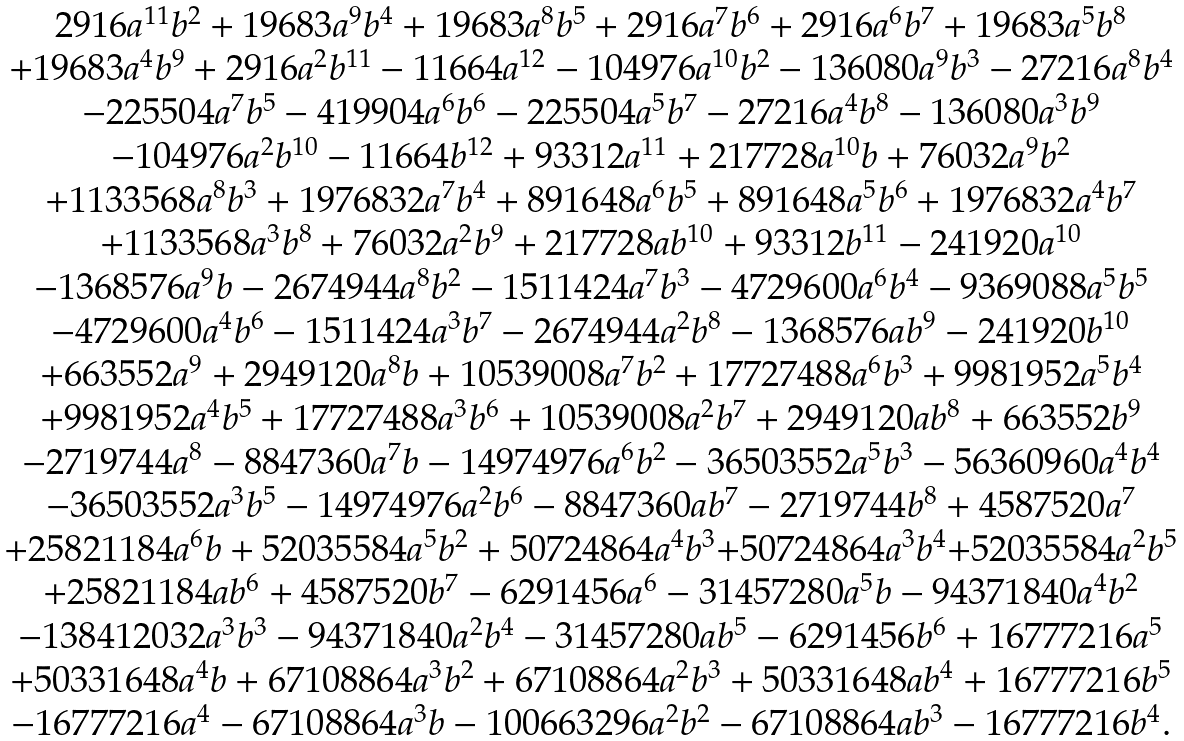Convert formula to latex. <formula><loc_0><loc_0><loc_500><loc_500>\begin{matrix} & 2 9 1 6 a ^ { 1 1 } b ^ { 2 } + 1 9 6 8 3 a ^ { 9 } b ^ { 4 } + 1 9 6 8 3 a ^ { 8 } b ^ { 5 } + 2 9 1 6 a ^ { 7 } b ^ { 6 } + 2 9 1 6 a ^ { 6 } b ^ { 7 } + 1 9 6 8 3 a ^ { 5 } b ^ { 8 } \\ & + 1 9 6 8 3 a ^ { 4 } b ^ { 9 } + 2 9 1 6 a ^ { 2 } b ^ { 1 1 } - 1 1 6 6 4 a ^ { 1 2 } - 1 0 4 9 7 6 a ^ { 1 0 } b ^ { 2 } - 1 3 6 0 8 0 a ^ { 9 } b ^ { 3 } - 2 7 2 1 6 a ^ { 8 } b ^ { 4 } \\ & - 2 2 5 5 0 4 a ^ { 7 } b ^ { 5 } - 4 1 9 9 0 4 a ^ { 6 } b ^ { 6 } - 2 2 5 5 0 4 a ^ { 5 } b ^ { 7 } - 2 7 2 1 6 a ^ { 4 } b ^ { 8 } - 1 3 6 0 8 0 a ^ { 3 } b ^ { 9 } \\ & - 1 0 4 9 7 6 a ^ { 2 } b ^ { 1 0 } - 1 1 6 6 4 b ^ { 1 2 } + 9 3 3 1 2 a ^ { 1 1 } + 2 1 7 7 2 8 a ^ { 1 0 } b + 7 6 0 3 2 a ^ { 9 } b ^ { 2 } \\ & + 1 1 3 3 5 6 8 a ^ { 8 } b ^ { 3 } + 1 9 7 6 8 3 2 a ^ { 7 } b ^ { 4 } + 8 9 1 6 4 8 a ^ { 6 } b ^ { 5 } + 8 9 1 6 4 8 a ^ { 5 } b ^ { 6 } + 1 9 7 6 8 3 2 a ^ { 4 } b ^ { 7 } \\ & + 1 1 3 3 5 6 8 a ^ { 3 } b ^ { 8 } + 7 6 0 3 2 a ^ { 2 } b ^ { 9 } + 2 1 7 7 2 8 a b ^ { 1 0 } + 9 3 3 1 2 b ^ { 1 1 } - 2 4 1 9 2 0 a ^ { 1 0 } \\ & - 1 3 6 8 5 7 6 a ^ { 9 } b - 2 6 7 4 9 4 4 a ^ { 8 } b ^ { 2 } - 1 5 1 1 4 2 4 a ^ { 7 } b ^ { 3 } - 4 7 2 9 6 0 0 a ^ { 6 } b ^ { 4 } - 9 3 6 9 0 8 8 a ^ { 5 } b ^ { 5 } \\ & - 4 7 2 9 6 0 0 a ^ { 4 } b ^ { 6 } - 1 5 1 1 4 2 4 a ^ { 3 } b ^ { 7 } - 2 6 7 4 9 4 4 a ^ { 2 } b ^ { 8 } - 1 3 6 8 5 7 6 a b ^ { 9 } - 2 4 1 9 2 0 b ^ { 1 0 } \\ & + 6 6 3 5 5 2 a ^ { 9 } + 2 9 4 9 1 2 0 a ^ { 8 } b + 1 0 5 3 9 0 0 8 a ^ { 7 } b ^ { 2 } + 1 7 7 2 7 4 8 8 a ^ { 6 } b ^ { 3 } + 9 9 8 1 9 5 2 a ^ { 5 } b ^ { 4 } \\ & + 9 9 8 1 9 5 2 a ^ { 4 } b ^ { 5 } + 1 7 7 2 7 4 8 8 a ^ { 3 } b ^ { 6 } + 1 0 5 3 9 0 0 8 a ^ { 2 } b ^ { 7 } + 2 9 4 9 1 2 0 a b ^ { 8 } + 6 6 3 5 5 2 b ^ { 9 } \\ & - 2 7 1 9 7 4 4 a ^ { 8 } - 8 8 4 7 3 6 0 a ^ { 7 } b - 1 4 9 7 4 9 7 6 a ^ { 6 } b ^ { 2 } - 3 6 5 0 3 5 5 2 a ^ { 5 } b ^ { 3 } - 5 6 3 6 0 9 6 0 a ^ { 4 } b ^ { 4 } \\ & - 3 6 5 0 3 5 5 2 a ^ { 3 } b ^ { 5 } - 1 4 9 7 4 9 7 6 a ^ { 2 } b ^ { 6 } - 8 8 4 7 3 6 0 a b ^ { 7 } - 2 7 1 9 7 4 4 b ^ { 8 } + 4 5 8 7 5 2 0 a ^ { 7 } \\ & + 2 5 8 2 1 1 8 4 a ^ { 6 } b + 5 2 0 3 5 5 8 4 a ^ { 5 } b ^ { 2 } + 5 0 7 2 4 8 6 4 a ^ { 4 } b ^ { 3 } { + } 5 0 7 2 4 8 6 4 a ^ { 3 } b ^ { 4 } { + } 5 2 0 3 5 5 8 4 a ^ { 2 } b ^ { 5 } \\ & + 2 5 8 2 1 1 8 4 a b ^ { 6 } + 4 5 8 7 5 2 0 b ^ { 7 } - 6 2 9 1 4 5 6 a ^ { 6 } - 3 1 4 5 7 2 8 0 a ^ { 5 } b - 9 4 3 7 1 8 4 0 a ^ { 4 } b ^ { 2 } \\ & - 1 3 8 4 1 2 0 3 2 a ^ { 3 } b ^ { 3 } - 9 4 3 7 1 8 4 0 a ^ { 2 } b ^ { 4 } - 3 1 4 5 7 2 8 0 a b ^ { 5 } - 6 2 9 1 4 5 6 b ^ { 6 } + 1 6 7 7 7 2 1 6 a ^ { 5 } \\ & + 5 0 3 3 1 6 4 8 a ^ { 4 } b + 6 7 1 0 8 8 6 4 a ^ { 3 } b ^ { 2 } + 6 7 1 0 8 8 6 4 a ^ { 2 } b ^ { 3 } + 5 0 3 3 1 6 4 8 a b ^ { 4 } + 1 6 7 7 7 2 1 6 b ^ { 5 } \\ & - 1 6 7 7 7 2 1 6 a ^ { 4 } - 6 7 1 0 8 8 6 4 a ^ { 3 } b - 1 0 0 6 6 3 2 9 6 a ^ { 2 } b ^ { 2 } - 6 7 1 0 8 8 6 4 a b ^ { 3 } - 1 6 7 7 7 2 1 6 b ^ { 4 } . \end{matrix}</formula> 